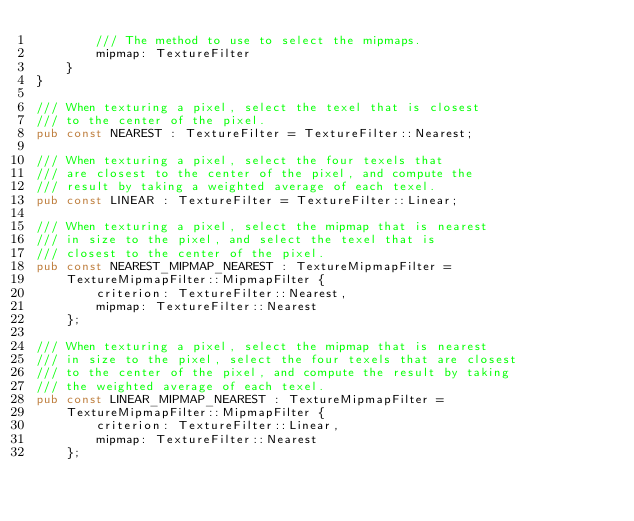<code> <loc_0><loc_0><loc_500><loc_500><_Rust_>        /// The method to use to select the mipmaps.
        mipmap: TextureFilter
    }
}

/// When texturing a pixel, select the texel that is closest
/// to the center of the pixel.
pub const NEAREST : TextureFilter = TextureFilter::Nearest;

/// When texturing a pixel, select the four texels that
/// are closest to the center of the pixel, and compute the
/// result by taking a weighted average of each texel.
pub const LINEAR : TextureFilter = TextureFilter::Linear;

/// When texturing a pixel, select the mipmap that is nearest
/// in size to the pixel, and select the texel that is
/// closest to the center of the pixel.
pub const NEAREST_MIPMAP_NEAREST : TextureMipmapFilter =
    TextureMipmapFilter::MipmapFilter {
        criterion: TextureFilter::Nearest,
        mipmap: TextureFilter::Nearest
    };

/// When texturing a pixel, select the mipmap that is nearest
/// in size to the pixel, select the four texels that are closest
/// to the center of the pixel, and compute the result by taking
/// the weighted average of each texel.
pub const LINEAR_MIPMAP_NEAREST : TextureMipmapFilter =
    TextureMipmapFilter::MipmapFilter {
        criterion: TextureFilter::Linear,
        mipmap: TextureFilter::Nearest
    };
</code> 